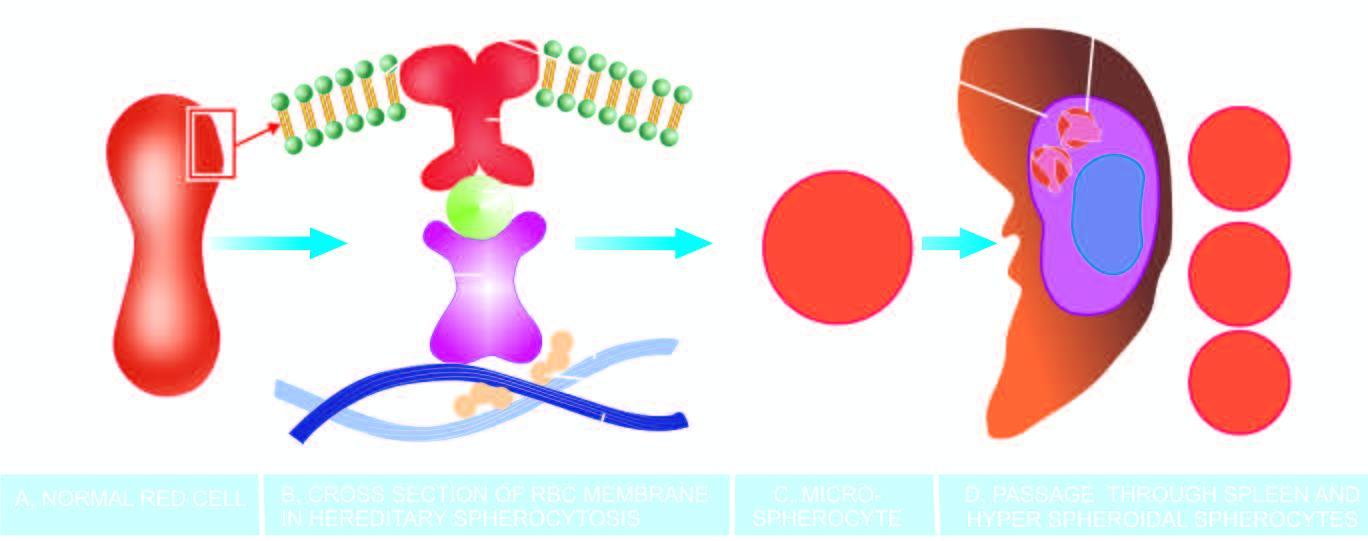what do these rigid spherical cells lose?
Answer the question using a single word or phrase. Their cell membrane further during passage through the spleen 